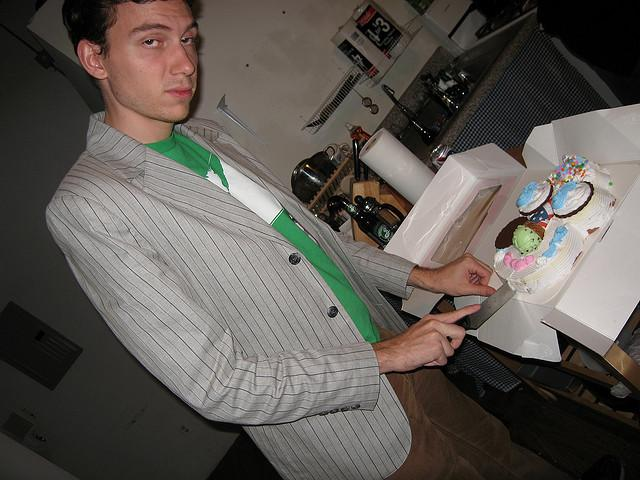What is inside the cake being cut? ice cream 